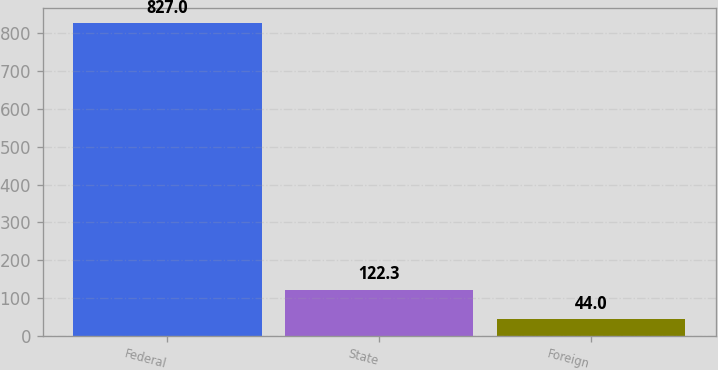Convert chart. <chart><loc_0><loc_0><loc_500><loc_500><bar_chart><fcel>Federal<fcel>State<fcel>Foreign<nl><fcel>827<fcel>122.3<fcel>44<nl></chart> 